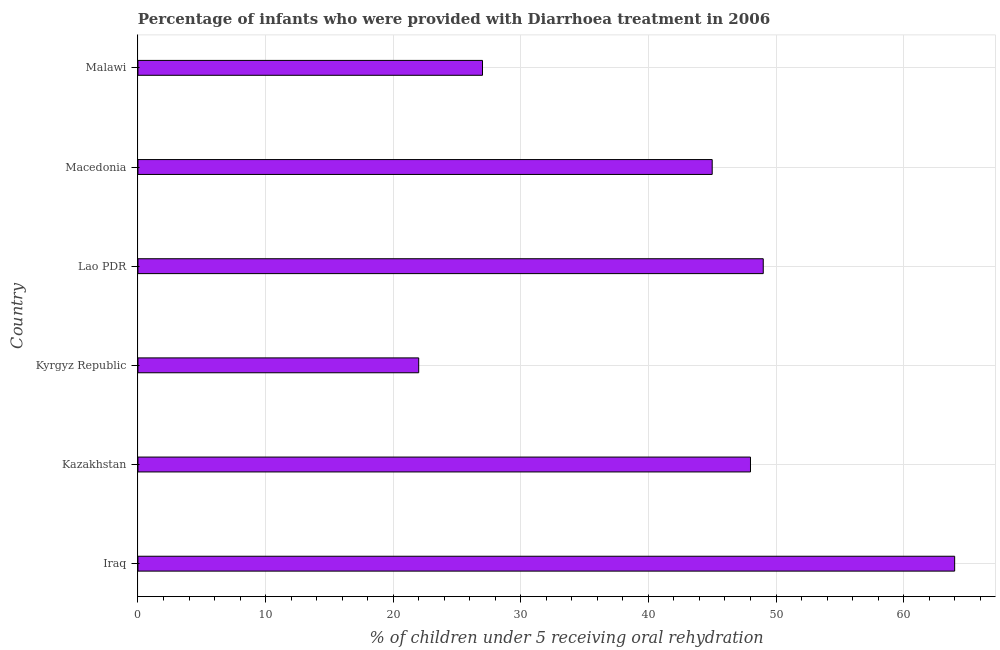Does the graph contain any zero values?
Provide a short and direct response. No. Does the graph contain grids?
Ensure brevity in your answer.  Yes. What is the title of the graph?
Your response must be concise. Percentage of infants who were provided with Diarrhoea treatment in 2006. What is the label or title of the X-axis?
Make the answer very short. % of children under 5 receiving oral rehydration. Across all countries, what is the minimum percentage of children who were provided with treatment diarrhoea?
Offer a very short reply. 22. In which country was the percentage of children who were provided with treatment diarrhoea maximum?
Offer a terse response. Iraq. In which country was the percentage of children who were provided with treatment diarrhoea minimum?
Your answer should be compact. Kyrgyz Republic. What is the sum of the percentage of children who were provided with treatment diarrhoea?
Offer a terse response. 255. What is the average percentage of children who were provided with treatment diarrhoea per country?
Give a very brief answer. 42.5. What is the median percentage of children who were provided with treatment diarrhoea?
Your answer should be very brief. 46.5. What is the ratio of the percentage of children who were provided with treatment diarrhoea in Kyrgyz Republic to that in Lao PDR?
Keep it short and to the point. 0.45. Is the percentage of children who were provided with treatment diarrhoea in Kazakhstan less than that in Kyrgyz Republic?
Your answer should be very brief. No. Is the difference between the percentage of children who were provided with treatment diarrhoea in Iraq and Macedonia greater than the difference between any two countries?
Ensure brevity in your answer.  No. What is the difference between the highest and the second highest percentage of children who were provided with treatment diarrhoea?
Make the answer very short. 15. What is the difference between the highest and the lowest percentage of children who were provided with treatment diarrhoea?
Offer a terse response. 42. In how many countries, is the percentage of children who were provided with treatment diarrhoea greater than the average percentage of children who were provided with treatment diarrhoea taken over all countries?
Offer a terse response. 4. How many bars are there?
Provide a short and direct response. 6. Are all the bars in the graph horizontal?
Provide a short and direct response. Yes. How many countries are there in the graph?
Offer a terse response. 6. What is the difference between two consecutive major ticks on the X-axis?
Keep it short and to the point. 10. Are the values on the major ticks of X-axis written in scientific E-notation?
Your answer should be very brief. No. What is the % of children under 5 receiving oral rehydration in Iraq?
Your response must be concise. 64. What is the % of children under 5 receiving oral rehydration in Macedonia?
Make the answer very short. 45. What is the % of children under 5 receiving oral rehydration of Malawi?
Provide a short and direct response. 27. What is the difference between the % of children under 5 receiving oral rehydration in Iraq and Kazakhstan?
Keep it short and to the point. 16. What is the difference between the % of children under 5 receiving oral rehydration in Iraq and Lao PDR?
Offer a very short reply. 15. What is the difference between the % of children under 5 receiving oral rehydration in Iraq and Macedonia?
Your answer should be very brief. 19. What is the difference between the % of children under 5 receiving oral rehydration in Kazakhstan and Macedonia?
Give a very brief answer. 3. What is the difference between the % of children under 5 receiving oral rehydration in Kazakhstan and Malawi?
Keep it short and to the point. 21. What is the difference between the % of children under 5 receiving oral rehydration in Kyrgyz Republic and Lao PDR?
Give a very brief answer. -27. What is the difference between the % of children under 5 receiving oral rehydration in Kyrgyz Republic and Macedonia?
Your answer should be very brief. -23. What is the difference between the % of children under 5 receiving oral rehydration in Lao PDR and Macedonia?
Provide a short and direct response. 4. What is the ratio of the % of children under 5 receiving oral rehydration in Iraq to that in Kazakhstan?
Your answer should be very brief. 1.33. What is the ratio of the % of children under 5 receiving oral rehydration in Iraq to that in Kyrgyz Republic?
Give a very brief answer. 2.91. What is the ratio of the % of children under 5 receiving oral rehydration in Iraq to that in Lao PDR?
Make the answer very short. 1.31. What is the ratio of the % of children under 5 receiving oral rehydration in Iraq to that in Macedonia?
Offer a terse response. 1.42. What is the ratio of the % of children under 5 receiving oral rehydration in Iraq to that in Malawi?
Keep it short and to the point. 2.37. What is the ratio of the % of children under 5 receiving oral rehydration in Kazakhstan to that in Kyrgyz Republic?
Provide a short and direct response. 2.18. What is the ratio of the % of children under 5 receiving oral rehydration in Kazakhstan to that in Lao PDR?
Your response must be concise. 0.98. What is the ratio of the % of children under 5 receiving oral rehydration in Kazakhstan to that in Macedonia?
Make the answer very short. 1.07. What is the ratio of the % of children under 5 receiving oral rehydration in Kazakhstan to that in Malawi?
Ensure brevity in your answer.  1.78. What is the ratio of the % of children under 5 receiving oral rehydration in Kyrgyz Republic to that in Lao PDR?
Give a very brief answer. 0.45. What is the ratio of the % of children under 5 receiving oral rehydration in Kyrgyz Republic to that in Macedonia?
Provide a succinct answer. 0.49. What is the ratio of the % of children under 5 receiving oral rehydration in Kyrgyz Republic to that in Malawi?
Your answer should be compact. 0.81. What is the ratio of the % of children under 5 receiving oral rehydration in Lao PDR to that in Macedonia?
Offer a very short reply. 1.09. What is the ratio of the % of children under 5 receiving oral rehydration in Lao PDR to that in Malawi?
Your response must be concise. 1.81. What is the ratio of the % of children under 5 receiving oral rehydration in Macedonia to that in Malawi?
Your answer should be very brief. 1.67. 